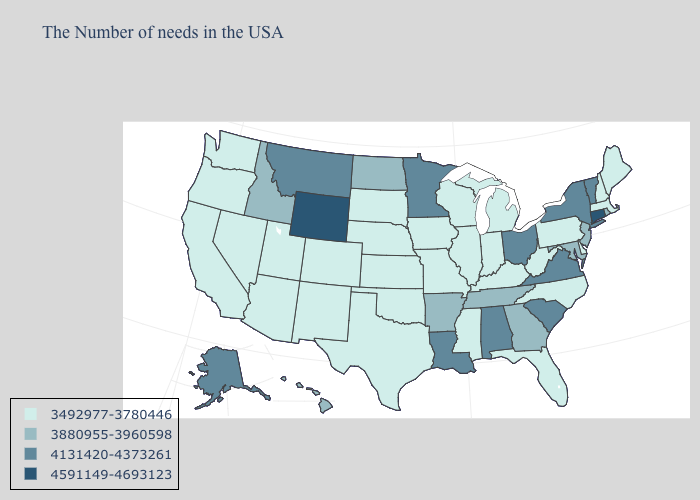Name the states that have a value in the range 3880955-3960598?
Short answer required. Rhode Island, New Jersey, Maryland, Georgia, Tennessee, Arkansas, North Dakota, Idaho, Hawaii. Name the states that have a value in the range 4131420-4373261?
Give a very brief answer. Vermont, New York, Virginia, South Carolina, Ohio, Alabama, Louisiana, Minnesota, Montana, Alaska. Name the states that have a value in the range 4591149-4693123?
Be succinct. Connecticut, Wyoming. Does Alabama have a lower value than Wyoming?
Concise answer only. Yes. What is the value of Oklahoma?
Give a very brief answer. 3492977-3780446. Does the map have missing data?
Keep it brief. No. Name the states that have a value in the range 4131420-4373261?
Answer briefly. Vermont, New York, Virginia, South Carolina, Ohio, Alabama, Louisiana, Minnesota, Montana, Alaska. Does Vermont have the highest value in the Northeast?
Be succinct. No. Among the states that border Minnesota , which have the lowest value?
Answer briefly. Wisconsin, Iowa, South Dakota. Which states have the lowest value in the South?
Give a very brief answer. Delaware, North Carolina, West Virginia, Florida, Kentucky, Mississippi, Oklahoma, Texas. What is the value of Arkansas?
Quick response, please. 3880955-3960598. Among the states that border Rhode Island , does Massachusetts have the highest value?
Give a very brief answer. No. Which states hav the highest value in the MidWest?
Answer briefly. Ohio, Minnesota. 